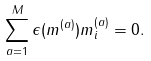<formula> <loc_0><loc_0><loc_500><loc_500>\sum _ { a = 1 } ^ { M } \epsilon ( m ^ { ( a ) } ) m _ { i } ^ { ( a ) } = 0 .</formula> 